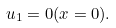Convert formula to latex. <formula><loc_0><loc_0><loc_500><loc_500>u _ { 1 } = 0 ( x = 0 ) .</formula> 